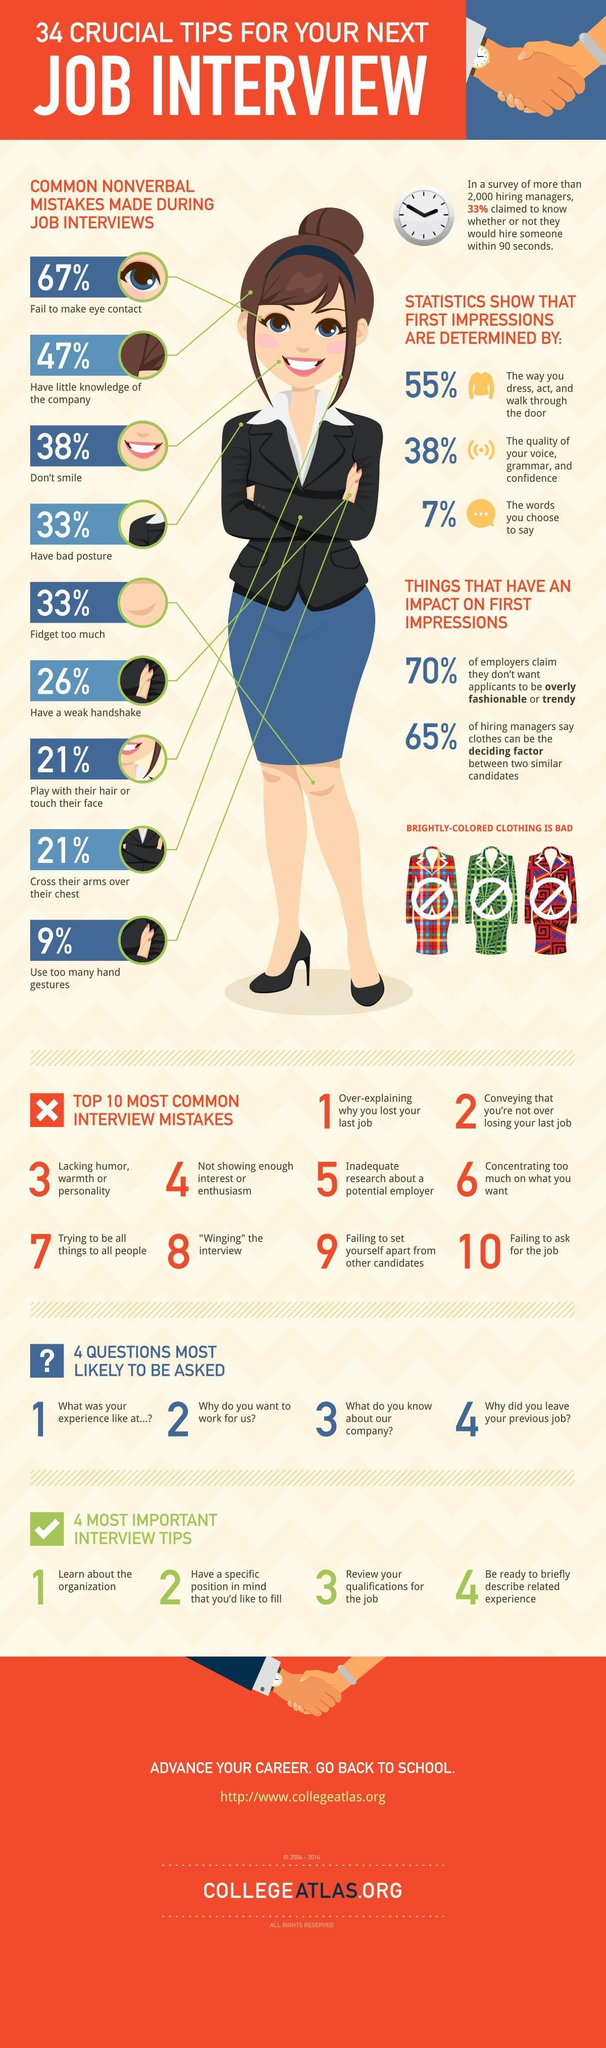what can be a deciding factor between two similar candidates
Answer the question with a short phrase. clothes that is interview top number 3 review your qualifications for the job how many fidget too much 33% to what extent do the words we choose determine the first imrepssion 7% what is common mistake number 5 inadequate research about a potential employer what is the second most important factor that determines first impression the quality of your voice, grammar, and confidence how many think that someone could be hired within 90 seconds 2000 